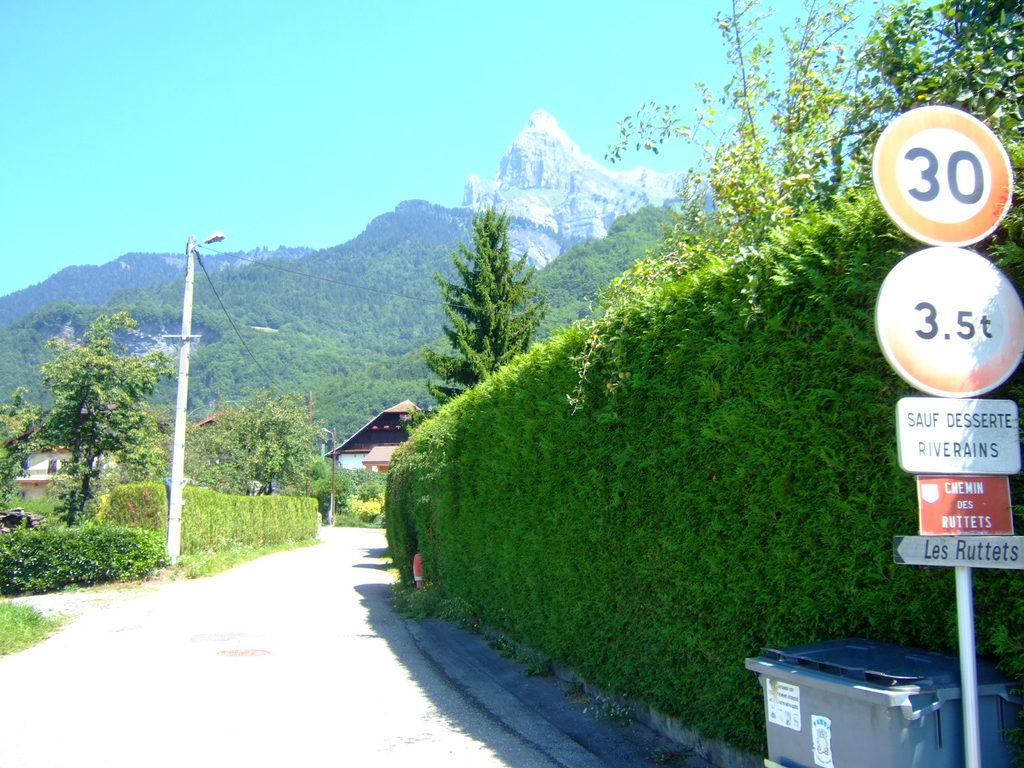<image>
Describe the image concisely. A circular sign that says 30 is over a circular sign that says 3.5t. 